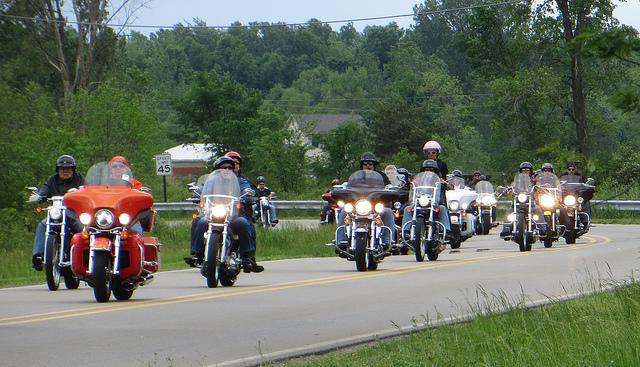What are the people doing with their motorcycles? Please explain your reasoning. parading. The people are going on a parade. 